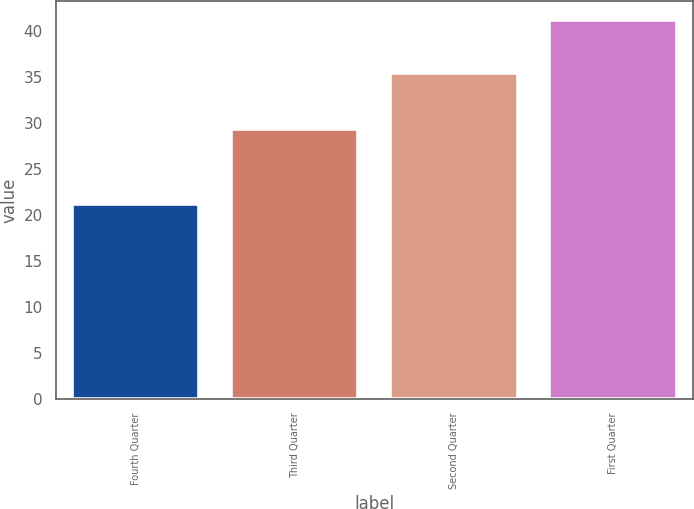<chart> <loc_0><loc_0><loc_500><loc_500><bar_chart><fcel>Fourth Quarter<fcel>Third Quarter<fcel>Second Quarter<fcel>First Quarter<nl><fcel>21.26<fcel>29.35<fcel>35.47<fcel>41.22<nl></chart> 